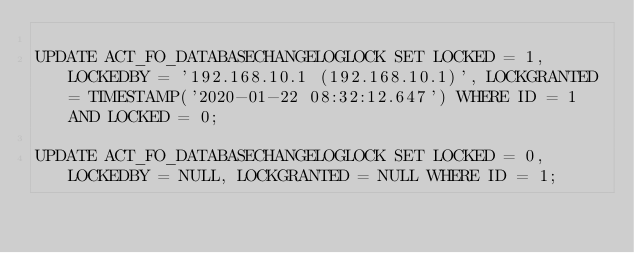Convert code to text. <code><loc_0><loc_0><loc_500><loc_500><_SQL_>
UPDATE ACT_FO_DATABASECHANGELOGLOCK SET LOCKED = 1, LOCKEDBY = '192.168.10.1 (192.168.10.1)', LOCKGRANTED = TIMESTAMP('2020-01-22 08:32:12.647') WHERE ID = 1 AND LOCKED = 0;

UPDATE ACT_FO_DATABASECHANGELOGLOCK SET LOCKED = 0, LOCKEDBY = NULL, LOCKGRANTED = NULL WHERE ID = 1;

</code> 